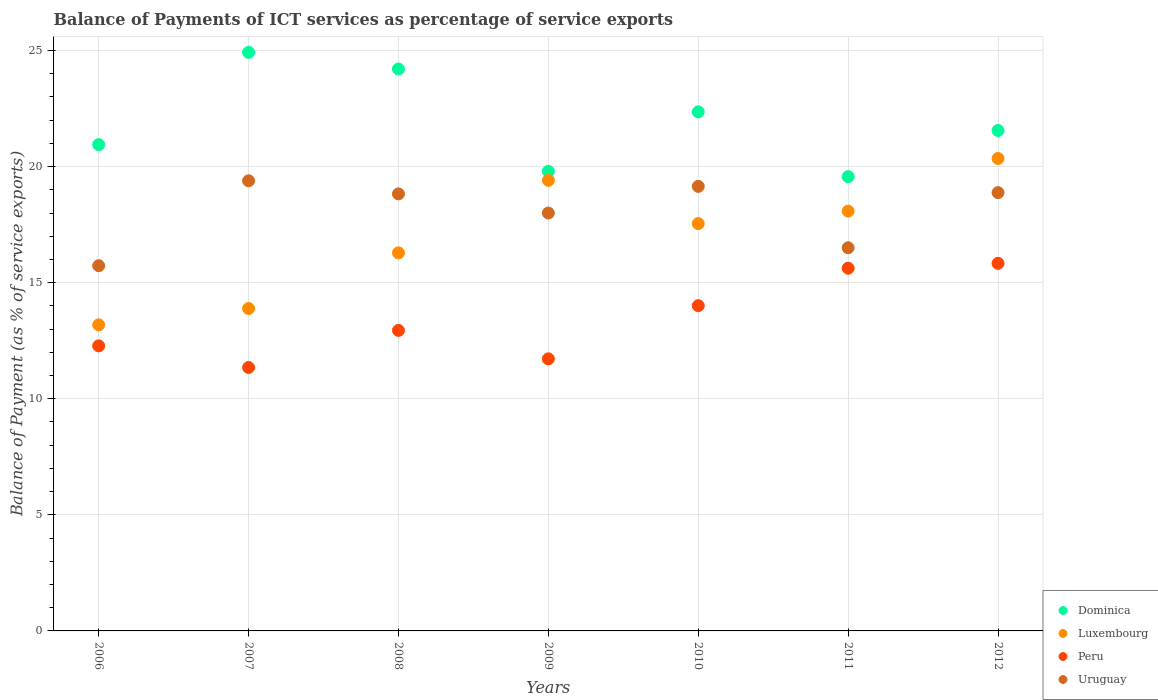How many different coloured dotlines are there?
Provide a short and direct response. 4. Is the number of dotlines equal to the number of legend labels?
Offer a very short reply. Yes. What is the balance of payments of ICT services in Dominica in 2007?
Ensure brevity in your answer.  24.92. Across all years, what is the maximum balance of payments of ICT services in Dominica?
Your answer should be very brief. 24.92. Across all years, what is the minimum balance of payments of ICT services in Peru?
Offer a terse response. 11.35. In which year was the balance of payments of ICT services in Luxembourg maximum?
Give a very brief answer. 2012. What is the total balance of payments of ICT services in Uruguay in the graph?
Keep it short and to the point. 126.48. What is the difference between the balance of payments of ICT services in Luxembourg in 2009 and that in 2011?
Keep it short and to the point. 1.33. What is the difference between the balance of payments of ICT services in Peru in 2010 and the balance of payments of ICT services in Dominica in 2008?
Give a very brief answer. -10.19. What is the average balance of payments of ICT services in Luxembourg per year?
Offer a very short reply. 16.96. In the year 2011, what is the difference between the balance of payments of ICT services in Peru and balance of payments of ICT services in Uruguay?
Offer a very short reply. -0.88. In how many years, is the balance of payments of ICT services in Peru greater than 3 %?
Offer a very short reply. 7. What is the ratio of the balance of payments of ICT services in Dominica in 2009 to that in 2011?
Keep it short and to the point. 1.01. Is the balance of payments of ICT services in Dominica in 2007 less than that in 2012?
Make the answer very short. No. What is the difference between the highest and the second highest balance of payments of ICT services in Dominica?
Keep it short and to the point. 0.72. What is the difference between the highest and the lowest balance of payments of ICT services in Dominica?
Make the answer very short. 5.36. In how many years, is the balance of payments of ICT services in Luxembourg greater than the average balance of payments of ICT services in Luxembourg taken over all years?
Your answer should be very brief. 4. Is the sum of the balance of payments of ICT services in Luxembourg in 2009 and 2010 greater than the maximum balance of payments of ICT services in Peru across all years?
Your response must be concise. Yes. Is it the case that in every year, the sum of the balance of payments of ICT services in Dominica and balance of payments of ICT services in Uruguay  is greater than the sum of balance of payments of ICT services in Luxembourg and balance of payments of ICT services in Peru?
Your response must be concise. No. Is it the case that in every year, the sum of the balance of payments of ICT services in Luxembourg and balance of payments of ICT services in Dominica  is greater than the balance of payments of ICT services in Peru?
Keep it short and to the point. Yes. How many years are there in the graph?
Your answer should be compact. 7. Are the values on the major ticks of Y-axis written in scientific E-notation?
Give a very brief answer. No. Does the graph contain grids?
Give a very brief answer. Yes. What is the title of the graph?
Your answer should be very brief. Balance of Payments of ICT services as percentage of service exports. What is the label or title of the X-axis?
Ensure brevity in your answer.  Years. What is the label or title of the Y-axis?
Make the answer very short. Balance of Payment (as % of service exports). What is the Balance of Payment (as % of service exports) in Dominica in 2006?
Your answer should be very brief. 20.95. What is the Balance of Payment (as % of service exports) of Luxembourg in 2006?
Your answer should be very brief. 13.18. What is the Balance of Payment (as % of service exports) of Peru in 2006?
Make the answer very short. 12.28. What is the Balance of Payment (as % of service exports) of Uruguay in 2006?
Your response must be concise. 15.73. What is the Balance of Payment (as % of service exports) of Dominica in 2007?
Keep it short and to the point. 24.92. What is the Balance of Payment (as % of service exports) in Luxembourg in 2007?
Offer a very short reply. 13.89. What is the Balance of Payment (as % of service exports) in Peru in 2007?
Your answer should be very brief. 11.35. What is the Balance of Payment (as % of service exports) in Uruguay in 2007?
Give a very brief answer. 19.39. What is the Balance of Payment (as % of service exports) of Dominica in 2008?
Your response must be concise. 24.2. What is the Balance of Payment (as % of service exports) in Luxembourg in 2008?
Give a very brief answer. 16.28. What is the Balance of Payment (as % of service exports) of Peru in 2008?
Provide a succinct answer. 12.94. What is the Balance of Payment (as % of service exports) in Uruguay in 2008?
Offer a very short reply. 18.83. What is the Balance of Payment (as % of service exports) of Dominica in 2009?
Keep it short and to the point. 19.8. What is the Balance of Payment (as % of service exports) in Luxembourg in 2009?
Make the answer very short. 19.41. What is the Balance of Payment (as % of service exports) of Peru in 2009?
Provide a short and direct response. 11.72. What is the Balance of Payment (as % of service exports) in Uruguay in 2009?
Provide a short and direct response. 18. What is the Balance of Payment (as % of service exports) of Dominica in 2010?
Provide a succinct answer. 22.36. What is the Balance of Payment (as % of service exports) in Luxembourg in 2010?
Provide a short and direct response. 17.55. What is the Balance of Payment (as % of service exports) in Peru in 2010?
Your answer should be compact. 14.01. What is the Balance of Payment (as % of service exports) in Uruguay in 2010?
Your answer should be compact. 19.15. What is the Balance of Payment (as % of service exports) of Dominica in 2011?
Keep it short and to the point. 19.57. What is the Balance of Payment (as % of service exports) in Luxembourg in 2011?
Offer a terse response. 18.08. What is the Balance of Payment (as % of service exports) in Peru in 2011?
Provide a succinct answer. 15.62. What is the Balance of Payment (as % of service exports) of Uruguay in 2011?
Give a very brief answer. 16.5. What is the Balance of Payment (as % of service exports) in Dominica in 2012?
Make the answer very short. 21.56. What is the Balance of Payment (as % of service exports) in Luxembourg in 2012?
Provide a short and direct response. 20.35. What is the Balance of Payment (as % of service exports) in Peru in 2012?
Provide a short and direct response. 15.83. What is the Balance of Payment (as % of service exports) of Uruguay in 2012?
Your answer should be compact. 18.88. Across all years, what is the maximum Balance of Payment (as % of service exports) in Dominica?
Ensure brevity in your answer.  24.92. Across all years, what is the maximum Balance of Payment (as % of service exports) of Luxembourg?
Keep it short and to the point. 20.35. Across all years, what is the maximum Balance of Payment (as % of service exports) of Peru?
Your answer should be very brief. 15.83. Across all years, what is the maximum Balance of Payment (as % of service exports) in Uruguay?
Offer a terse response. 19.39. Across all years, what is the minimum Balance of Payment (as % of service exports) of Dominica?
Provide a short and direct response. 19.57. Across all years, what is the minimum Balance of Payment (as % of service exports) of Luxembourg?
Your response must be concise. 13.18. Across all years, what is the minimum Balance of Payment (as % of service exports) of Peru?
Keep it short and to the point. 11.35. Across all years, what is the minimum Balance of Payment (as % of service exports) in Uruguay?
Provide a succinct answer. 15.73. What is the total Balance of Payment (as % of service exports) of Dominica in the graph?
Make the answer very short. 153.35. What is the total Balance of Payment (as % of service exports) of Luxembourg in the graph?
Give a very brief answer. 118.74. What is the total Balance of Payment (as % of service exports) in Peru in the graph?
Provide a succinct answer. 93.76. What is the total Balance of Payment (as % of service exports) of Uruguay in the graph?
Make the answer very short. 126.48. What is the difference between the Balance of Payment (as % of service exports) of Dominica in 2006 and that in 2007?
Offer a very short reply. -3.98. What is the difference between the Balance of Payment (as % of service exports) of Luxembourg in 2006 and that in 2007?
Offer a very short reply. -0.7. What is the difference between the Balance of Payment (as % of service exports) of Peru in 2006 and that in 2007?
Keep it short and to the point. 0.93. What is the difference between the Balance of Payment (as % of service exports) in Uruguay in 2006 and that in 2007?
Offer a very short reply. -3.66. What is the difference between the Balance of Payment (as % of service exports) of Dominica in 2006 and that in 2008?
Ensure brevity in your answer.  -3.26. What is the difference between the Balance of Payment (as % of service exports) in Luxembourg in 2006 and that in 2008?
Make the answer very short. -3.1. What is the difference between the Balance of Payment (as % of service exports) of Peru in 2006 and that in 2008?
Provide a short and direct response. -0.67. What is the difference between the Balance of Payment (as % of service exports) of Uruguay in 2006 and that in 2008?
Provide a succinct answer. -3.09. What is the difference between the Balance of Payment (as % of service exports) of Dominica in 2006 and that in 2009?
Make the answer very short. 1.15. What is the difference between the Balance of Payment (as % of service exports) of Luxembourg in 2006 and that in 2009?
Give a very brief answer. -6.22. What is the difference between the Balance of Payment (as % of service exports) in Peru in 2006 and that in 2009?
Offer a very short reply. 0.56. What is the difference between the Balance of Payment (as % of service exports) in Uruguay in 2006 and that in 2009?
Provide a short and direct response. -2.27. What is the difference between the Balance of Payment (as % of service exports) in Dominica in 2006 and that in 2010?
Offer a terse response. -1.41. What is the difference between the Balance of Payment (as % of service exports) of Luxembourg in 2006 and that in 2010?
Provide a short and direct response. -4.36. What is the difference between the Balance of Payment (as % of service exports) of Peru in 2006 and that in 2010?
Your answer should be compact. -1.73. What is the difference between the Balance of Payment (as % of service exports) in Uruguay in 2006 and that in 2010?
Keep it short and to the point. -3.42. What is the difference between the Balance of Payment (as % of service exports) of Dominica in 2006 and that in 2011?
Keep it short and to the point. 1.38. What is the difference between the Balance of Payment (as % of service exports) in Luxembourg in 2006 and that in 2011?
Offer a very short reply. -4.9. What is the difference between the Balance of Payment (as % of service exports) in Peru in 2006 and that in 2011?
Ensure brevity in your answer.  -3.34. What is the difference between the Balance of Payment (as % of service exports) of Uruguay in 2006 and that in 2011?
Ensure brevity in your answer.  -0.77. What is the difference between the Balance of Payment (as % of service exports) of Dominica in 2006 and that in 2012?
Your response must be concise. -0.61. What is the difference between the Balance of Payment (as % of service exports) in Luxembourg in 2006 and that in 2012?
Your answer should be compact. -7.17. What is the difference between the Balance of Payment (as % of service exports) of Peru in 2006 and that in 2012?
Your answer should be very brief. -3.55. What is the difference between the Balance of Payment (as % of service exports) in Uruguay in 2006 and that in 2012?
Your answer should be compact. -3.15. What is the difference between the Balance of Payment (as % of service exports) of Dominica in 2007 and that in 2008?
Provide a succinct answer. 0.72. What is the difference between the Balance of Payment (as % of service exports) in Luxembourg in 2007 and that in 2008?
Offer a terse response. -2.4. What is the difference between the Balance of Payment (as % of service exports) in Peru in 2007 and that in 2008?
Offer a very short reply. -1.6. What is the difference between the Balance of Payment (as % of service exports) in Uruguay in 2007 and that in 2008?
Ensure brevity in your answer.  0.56. What is the difference between the Balance of Payment (as % of service exports) of Dominica in 2007 and that in 2009?
Provide a succinct answer. 5.12. What is the difference between the Balance of Payment (as % of service exports) of Luxembourg in 2007 and that in 2009?
Offer a very short reply. -5.52. What is the difference between the Balance of Payment (as % of service exports) of Peru in 2007 and that in 2009?
Offer a very short reply. -0.37. What is the difference between the Balance of Payment (as % of service exports) in Uruguay in 2007 and that in 2009?
Ensure brevity in your answer.  1.39. What is the difference between the Balance of Payment (as % of service exports) of Dominica in 2007 and that in 2010?
Keep it short and to the point. 2.56. What is the difference between the Balance of Payment (as % of service exports) in Luxembourg in 2007 and that in 2010?
Your answer should be very brief. -3.66. What is the difference between the Balance of Payment (as % of service exports) in Peru in 2007 and that in 2010?
Your answer should be very brief. -2.66. What is the difference between the Balance of Payment (as % of service exports) in Uruguay in 2007 and that in 2010?
Give a very brief answer. 0.24. What is the difference between the Balance of Payment (as % of service exports) in Dominica in 2007 and that in 2011?
Give a very brief answer. 5.36. What is the difference between the Balance of Payment (as % of service exports) in Luxembourg in 2007 and that in 2011?
Keep it short and to the point. -4.2. What is the difference between the Balance of Payment (as % of service exports) in Peru in 2007 and that in 2011?
Make the answer very short. -4.28. What is the difference between the Balance of Payment (as % of service exports) of Uruguay in 2007 and that in 2011?
Make the answer very short. 2.89. What is the difference between the Balance of Payment (as % of service exports) in Dominica in 2007 and that in 2012?
Your response must be concise. 3.37. What is the difference between the Balance of Payment (as % of service exports) in Luxembourg in 2007 and that in 2012?
Your answer should be compact. -6.46. What is the difference between the Balance of Payment (as % of service exports) of Peru in 2007 and that in 2012?
Offer a very short reply. -4.49. What is the difference between the Balance of Payment (as % of service exports) in Uruguay in 2007 and that in 2012?
Ensure brevity in your answer.  0.51. What is the difference between the Balance of Payment (as % of service exports) of Dominica in 2008 and that in 2009?
Provide a succinct answer. 4.4. What is the difference between the Balance of Payment (as % of service exports) in Luxembourg in 2008 and that in 2009?
Your answer should be compact. -3.12. What is the difference between the Balance of Payment (as % of service exports) of Peru in 2008 and that in 2009?
Offer a terse response. 1.22. What is the difference between the Balance of Payment (as % of service exports) in Uruguay in 2008 and that in 2009?
Your response must be concise. 0.83. What is the difference between the Balance of Payment (as % of service exports) in Dominica in 2008 and that in 2010?
Keep it short and to the point. 1.84. What is the difference between the Balance of Payment (as % of service exports) of Luxembourg in 2008 and that in 2010?
Your answer should be very brief. -1.26. What is the difference between the Balance of Payment (as % of service exports) of Peru in 2008 and that in 2010?
Your response must be concise. -1.07. What is the difference between the Balance of Payment (as % of service exports) of Uruguay in 2008 and that in 2010?
Offer a terse response. -0.32. What is the difference between the Balance of Payment (as % of service exports) in Dominica in 2008 and that in 2011?
Your answer should be compact. 4.64. What is the difference between the Balance of Payment (as % of service exports) in Luxembourg in 2008 and that in 2011?
Your answer should be very brief. -1.8. What is the difference between the Balance of Payment (as % of service exports) of Peru in 2008 and that in 2011?
Your response must be concise. -2.68. What is the difference between the Balance of Payment (as % of service exports) in Uruguay in 2008 and that in 2011?
Provide a succinct answer. 2.32. What is the difference between the Balance of Payment (as % of service exports) in Dominica in 2008 and that in 2012?
Provide a succinct answer. 2.65. What is the difference between the Balance of Payment (as % of service exports) in Luxembourg in 2008 and that in 2012?
Your answer should be compact. -4.07. What is the difference between the Balance of Payment (as % of service exports) in Peru in 2008 and that in 2012?
Your response must be concise. -2.89. What is the difference between the Balance of Payment (as % of service exports) in Uruguay in 2008 and that in 2012?
Give a very brief answer. -0.05. What is the difference between the Balance of Payment (as % of service exports) in Dominica in 2009 and that in 2010?
Keep it short and to the point. -2.56. What is the difference between the Balance of Payment (as % of service exports) of Luxembourg in 2009 and that in 2010?
Give a very brief answer. 1.86. What is the difference between the Balance of Payment (as % of service exports) in Peru in 2009 and that in 2010?
Give a very brief answer. -2.29. What is the difference between the Balance of Payment (as % of service exports) in Uruguay in 2009 and that in 2010?
Give a very brief answer. -1.15. What is the difference between the Balance of Payment (as % of service exports) of Dominica in 2009 and that in 2011?
Ensure brevity in your answer.  0.23. What is the difference between the Balance of Payment (as % of service exports) of Luxembourg in 2009 and that in 2011?
Give a very brief answer. 1.33. What is the difference between the Balance of Payment (as % of service exports) of Peru in 2009 and that in 2011?
Provide a short and direct response. -3.9. What is the difference between the Balance of Payment (as % of service exports) of Uruguay in 2009 and that in 2011?
Ensure brevity in your answer.  1.5. What is the difference between the Balance of Payment (as % of service exports) in Dominica in 2009 and that in 2012?
Your answer should be compact. -1.76. What is the difference between the Balance of Payment (as % of service exports) in Luxembourg in 2009 and that in 2012?
Your answer should be compact. -0.94. What is the difference between the Balance of Payment (as % of service exports) in Peru in 2009 and that in 2012?
Offer a terse response. -4.11. What is the difference between the Balance of Payment (as % of service exports) in Uruguay in 2009 and that in 2012?
Give a very brief answer. -0.88. What is the difference between the Balance of Payment (as % of service exports) in Dominica in 2010 and that in 2011?
Give a very brief answer. 2.79. What is the difference between the Balance of Payment (as % of service exports) of Luxembourg in 2010 and that in 2011?
Offer a very short reply. -0.54. What is the difference between the Balance of Payment (as % of service exports) of Peru in 2010 and that in 2011?
Provide a short and direct response. -1.61. What is the difference between the Balance of Payment (as % of service exports) in Uruguay in 2010 and that in 2011?
Your answer should be compact. 2.64. What is the difference between the Balance of Payment (as % of service exports) of Dominica in 2010 and that in 2012?
Your answer should be compact. 0.8. What is the difference between the Balance of Payment (as % of service exports) in Luxembourg in 2010 and that in 2012?
Your answer should be compact. -2.8. What is the difference between the Balance of Payment (as % of service exports) of Peru in 2010 and that in 2012?
Keep it short and to the point. -1.82. What is the difference between the Balance of Payment (as % of service exports) of Uruguay in 2010 and that in 2012?
Ensure brevity in your answer.  0.27. What is the difference between the Balance of Payment (as % of service exports) in Dominica in 2011 and that in 2012?
Provide a succinct answer. -1.99. What is the difference between the Balance of Payment (as % of service exports) in Luxembourg in 2011 and that in 2012?
Make the answer very short. -2.27. What is the difference between the Balance of Payment (as % of service exports) in Peru in 2011 and that in 2012?
Keep it short and to the point. -0.21. What is the difference between the Balance of Payment (as % of service exports) in Uruguay in 2011 and that in 2012?
Make the answer very short. -2.38. What is the difference between the Balance of Payment (as % of service exports) of Dominica in 2006 and the Balance of Payment (as % of service exports) of Luxembourg in 2007?
Your answer should be compact. 7.06. What is the difference between the Balance of Payment (as % of service exports) of Dominica in 2006 and the Balance of Payment (as % of service exports) of Peru in 2007?
Make the answer very short. 9.6. What is the difference between the Balance of Payment (as % of service exports) of Dominica in 2006 and the Balance of Payment (as % of service exports) of Uruguay in 2007?
Give a very brief answer. 1.56. What is the difference between the Balance of Payment (as % of service exports) of Luxembourg in 2006 and the Balance of Payment (as % of service exports) of Peru in 2007?
Your answer should be compact. 1.84. What is the difference between the Balance of Payment (as % of service exports) in Luxembourg in 2006 and the Balance of Payment (as % of service exports) in Uruguay in 2007?
Your answer should be compact. -6.21. What is the difference between the Balance of Payment (as % of service exports) in Peru in 2006 and the Balance of Payment (as % of service exports) in Uruguay in 2007?
Provide a succinct answer. -7.11. What is the difference between the Balance of Payment (as % of service exports) of Dominica in 2006 and the Balance of Payment (as % of service exports) of Luxembourg in 2008?
Provide a short and direct response. 4.66. What is the difference between the Balance of Payment (as % of service exports) of Dominica in 2006 and the Balance of Payment (as % of service exports) of Peru in 2008?
Give a very brief answer. 8. What is the difference between the Balance of Payment (as % of service exports) in Dominica in 2006 and the Balance of Payment (as % of service exports) in Uruguay in 2008?
Your answer should be very brief. 2.12. What is the difference between the Balance of Payment (as % of service exports) of Luxembourg in 2006 and the Balance of Payment (as % of service exports) of Peru in 2008?
Your answer should be very brief. 0.24. What is the difference between the Balance of Payment (as % of service exports) of Luxembourg in 2006 and the Balance of Payment (as % of service exports) of Uruguay in 2008?
Your answer should be very brief. -5.64. What is the difference between the Balance of Payment (as % of service exports) in Peru in 2006 and the Balance of Payment (as % of service exports) in Uruguay in 2008?
Give a very brief answer. -6.55. What is the difference between the Balance of Payment (as % of service exports) in Dominica in 2006 and the Balance of Payment (as % of service exports) in Luxembourg in 2009?
Your response must be concise. 1.54. What is the difference between the Balance of Payment (as % of service exports) of Dominica in 2006 and the Balance of Payment (as % of service exports) of Peru in 2009?
Ensure brevity in your answer.  9.23. What is the difference between the Balance of Payment (as % of service exports) in Dominica in 2006 and the Balance of Payment (as % of service exports) in Uruguay in 2009?
Provide a short and direct response. 2.95. What is the difference between the Balance of Payment (as % of service exports) of Luxembourg in 2006 and the Balance of Payment (as % of service exports) of Peru in 2009?
Keep it short and to the point. 1.46. What is the difference between the Balance of Payment (as % of service exports) in Luxembourg in 2006 and the Balance of Payment (as % of service exports) in Uruguay in 2009?
Ensure brevity in your answer.  -4.82. What is the difference between the Balance of Payment (as % of service exports) of Peru in 2006 and the Balance of Payment (as % of service exports) of Uruguay in 2009?
Keep it short and to the point. -5.72. What is the difference between the Balance of Payment (as % of service exports) in Dominica in 2006 and the Balance of Payment (as % of service exports) in Luxembourg in 2010?
Your answer should be very brief. 3.4. What is the difference between the Balance of Payment (as % of service exports) of Dominica in 2006 and the Balance of Payment (as % of service exports) of Peru in 2010?
Provide a succinct answer. 6.94. What is the difference between the Balance of Payment (as % of service exports) in Dominica in 2006 and the Balance of Payment (as % of service exports) in Uruguay in 2010?
Ensure brevity in your answer.  1.8. What is the difference between the Balance of Payment (as % of service exports) in Luxembourg in 2006 and the Balance of Payment (as % of service exports) in Peru in 2010?
Your answer should be very brief. -0.83. What is the difference between the Balance of Payment (as % of service exports) in Luxembourg in 2006 and the Balance of Payment (as % of service exports) in Uruguay in 2010?
Your answer should be compact. -5.96. What is the difference between the Balance of Payment (as % of service exports) of Peru in 2006 and the Balance of Payment (as % of service exports) of Uruguay in 2010?
Provide a short and direct response. -6.87. What is the difference between the Balance of Payment (as % of service exports) of Dominica in 2006 and the Balance of Payment (as % of service exports) of Luxembourg in 2011?
Offer a very short reply. 2.86. What is the difference between the Balance of Payment (as % of service exports) of Dominica in 2006 and the Balance of Payment (as % of service exports) of Peru in 2011?
Your response must be concise. 5.32. What is the difference between the Balance of Payment (as % of service exports) in Dominica in 2006 and the Balance of Payment (as % of service exports) in Uruguay in 2011?
Give a very brief answer. 4.44. What is the difference between the Balance of Payment (as % of service exports) in Luxembourg in 2006 and the Balance of Payment (as % of service exports) in Peru in 2011?
Make the answer very short. -2.44. What is the difference between the Balance of Payment (as % of service exports) of Luxembourg in 2006 and the Balance of Payment (as % of service exports) of Uruguay in 2011?
Give a very brief answer. -3.32. What is the difference between the Balance of Payment (as % of service exports) of Peru in 2006 and the Balance of Payment (as % of service exports) of Uruguay in 2011?
Your response must be concise. -4.22. What is the difference between the Balance of Payment (as % of service exports) in Dominica in 2006 and the Balance of Payment (as % of service exports) in Luxembourg in 2012?
Offer a very short reply. 0.6. What is the difference between the Balance of Payment (as % of service exports) of Dominica in 2006 and the Balance of Payment (as % of service exports) of Peru in 2012?
Provide a succinct answer. 5.11. What is the difference between the Balance of Payment (as % of service exports) in Dominica in 2006 and the Balance of Payment (as % of service exports) in Uruguay in 2012?
Keep it short and to the point. 2.07. What is the difference between the Balance of Payment (as % of service exports) of Luxembourg in 2006 and the Balance of Payment (as % of service exports) of Peru in 2012?
Offer a very short reply. -2.65. What is the difference between the Balance of Payment (as % of service exports) in Luxembourg in 2006 and the Balance of Payment (as % of service exports) in Uruguay in 2012?
Provide a short and direct response. -5.7. What is the difference between the Balance of Payment (as % of service exports) in Peru in 2006 and the Balance of Payment (as % of service exports) in Uruguay in 2012?
Your answer should be compact. -6.6. What is the difference between the Balance of Payment (as % of service exports) of Dominica in 2007 and the Balance of Payment (as % of service exports) of Luxembourg in 2008?
Give a very brief answer. 8.64. What is the difference between the Balance of Payment (as % of service exports) in Dominica in 2007 and the Balance of Payment (as % of service exports) in Peru in 2008?
Provide a succinct answer. 11.98. What is the difference between the Balance of Payment (as % of service exports) of Dominica in 2007 and the Balance of Payment (as % of service exports) of Uruguay in 2008?
Offer a terse response. 6.1. What is the difference between the Balance of Payment (as % of service exports) in Luxembourg in 2007 and the Balance of Payment (as % of service exports) in Peru in 2008?
Keep it short and to the point. 0.94. What is the difference between the Balance of Payment (as % of service exports) of Luxembourg in 2007 and the Balance of Payment (as % of service exports) of Uruguay in 2008?
Your response must be concise. -4.94. What is the difference between the Balance of Payment (as % of service exports) in Peru in 2007 and the Balance of Payment (as % of service exports) in Uruguay in 2008?
Give a very brief answer. -7.48. What is the difference between the Balance of Payment (as % of service exports) in Dominica in 2007 and the Balance of Payment (as % of service exports) in Luxembourg in 2009?
Give a very brief answer. 5.51. What is the difference between the Balance of Payment (as % of service exports) of Dominica in 2007 and the Balance of Payment (as % of service exports) of Peru in 2009?
Provide a short and direct response. 13.2. What is the difference between the Balance of Payment (as % of service exports) in Dominica in 2007 and the Balance of Payment (as % of service exports) in Uruguay in 2009?
Offer a terse response. 6.92. What is the difference between the Balance of Payment (as % of service exports) of Luxembourg in 2007 and the Balance of Payment (as % of service exports) of Peru in 2009?
Your answer should be compact. 2.17. What is the difference between the Balance of Payment (as % of service exports) in Luxembourg in 2007 and the Balance of Payment (as % of service exports) in Uruguay in 2009?
Your response must be concise. -4.11. What is the difference between the Balance of Payment (as % of service exports) of Peru in 2007 and the Balance of Payment (as % of service exports) of Uruguay in 2009?
Offer a terse response. -6.65. What is the difference between the Balance of Payment (as % of service exports) of Dominica in 2007 and the Balance of Payment (as % of service exports) of Luxembourg in 2010?
Give a very brief answer. 7.38. What is the difference between the Balance of Payment (as % of service exports) of Dominica in 2007 and the Balance of Payment (as % of service exports) of Peru in 2010?
Provide a succinct answer. 10.91. What is the difference between the Balance of Payment (as % of service exports) of Dominica in 2007 and the Balance of Payment (as % of service exports) of Uruguay in 2010?
Offer a very short reply. 5.77. What is the difference between the Balance of Payment (as % of service exports) in Luxembourg in 2007 and the Balance of Payment (as % of service exports) in Peru in 2010?
Provide a short and direct response. -0.12. What is the difference between the Balance of Payment (as % of service exports) of Luxembourg in 2007 and the Balance of Payment (as % of service exports) of Uruguay in 2010?
Provide a short and direct response. -5.26. What is the difference between the Balance of Payment (as % of service exports) of Peru in 2007 and the Balance of Payment (as % of service exports) of Uruguay in 2010?
Make the answer very short. -7.8. What is the difference between the Balance of Payment (as % of service exports) of Dominica in 2007 and the Balance of Payment (as % of service exports) of Luxembourg in 2011?
Ensure brevity in your answer.  6.84. What is the difference between the Balance of Payment (as % of service exports) in Dominica in 2007 and the Balance of Payment (as % of service exports) in Peru in 2011?
Ensure brevity in your answer.  9.3. What is the difference between the Balance of Payment (as % of service exports) in Dominica in 2007 and the Balance of Payment (as % of service exports) in Uruguay in 2011?
Offer a terse response. 8.42. What is the difference between the Balance of Payment (as % of service exports) of Luxembourg in 2007 and the Balance of Payment (as % of service exports) of Peru in 2011?
Provide a short and direct response. -1.74. What is the difference between the Balance of Payment (as % of service exports) in Luxembourg in 2007 and the Balance of Payment (as % of service exports) in Uruguay in 2011?
Your answer should be very brief. -2.62. What is the difference between the Balance of Payment (as % of service exports) in Peru in 2007 and the Balance of Payment (as % of service exports) in Uruguay in 2011?
Keep it short and to the point. -5.16. What is the difference between the Balance of Payment (as % of service exports) of Dominica in 2007 and the Balance of Payment (as % of service exports) of Luxembourg in 2012?
Keep it short and to the point. 4.57. What is the difference between the Balance of Payment (as % of service exports) of Dominica in 2007 and the Balance of Payment (as % of service exports) of Peru in 2012?
Keep it short and to the point. 9.09. What is the difference between the Balance of Payment (as % of service exports) in Dominica in 2007 and the Balance of Payment (as % of service exports) in Uruguay in 2012?
Keep it short and to the point. 6.04. What is the difference between the Balance of Payment (as % of service exports) of Luxembourg in 2007 and the Balance of Payment (as % of service exports) of Peru in 2012?
Offer a terse response. -1.95. What is the difference between the Balance of Payment (as % of service exports) of Luxembourg in 2007 and the Balance of Payment (as % of service exports) of Uruguay in 2012?
Your answer should be very brief. -4.99. What is the difference between the Balance of Payment (as % of service exports) in Peru in 2007 and the Balance of Payment (as % of service exports) in Uruguay in 2012?
Provide a succinct answer. -7.53. What is the difference between the Balance of Payment (as % of service exports) in Dominica in 2008 and the Balance of Payment (as % of service exports) in Luxembourg in 2009?
Your response must be concise. 4.8. What is the difference between the Balance of Payment (as % of service exports) in Dominica in 2008 and the Balance of Payment (as % of service exports) in Peru in 2009?
Offer a terse response. 12.48. What is the difference between the Balance of Payment (as % of service exports) of Dominica in 2008 and the Balance of Payment (as % of service exports) of Uruguay in 2009?
Offer a very short reply. 6.2. What is the difference between the Balance of Payment (as % of service exports) in Luxembourg in 2008 and the Balance of Payment (as % of service exports) in Peru in 2009?
Ensure brevity in your answer.  4.56. What is the difference between the Balance of Payment (as % of service exports) in Luxembourg in 2008 and the Balance of Payment (as % of service exports) in Uruguay in 2009?
Provide a succinct answer. -1.72. What is the difference between the Balance of Payment (as % of service exports) of Peru in 2008 and the Balance of Payment (as % of service exports) of Uruguay in 2009?
Your response must be concise. -5.06. What is the difference between the Balance of Payment (as % of service exports) in Dominica in 2008 and the Balance of Payment (as % of service exports) in Luxembourg in 2010?
Your response must be concise. 6.66. What is the difference between the Balance of Payment (as % of service exports) of Dominica in 2008 and the Balance of Payment (as % of service exports) of Peru in 2010?
Your response must be concise. 10.19. What is the difference between the Balance of Payment (as % of service exports) of Dominica in 2008 and the Balance of Payment (as % of service exports) of Uruguay in 2010?
Offer a very short reply. 5.05. What is the difference between the Balance of Payment (as % of service exports) in Luxembourg in 2008 and the Balance of Payment (as % of service exports) in Peru in 2010?
Your answer should be compact. 2.27. What is the difference between the Balance of Payment (as % of service exports) in Luxembourg in 2008 and the Balance of Payment (as % of service exports) in Uruguay in 2010?
Ensure brevity in your answer.  -2.86. What is the difference between the Balance of Payment (as % of service exports) of Peru in 2008 and the Balance of Payment (as % of service exports) of Uruguay in 2010?
Keep it short and to the point. -6.2. What is the difference between the Balance of Payment (as % of service exports) in Dominica in 2008 and the Balance of Payment (as % of service exports) in Luxembourg in 2011?
Ensure brevity in your answer.  6.12. What is the difference between the Balance of Payment (as % of service exports) in Dominica in 2008 and the Balance of Payment (as % of service exports) in Peru in 2011?
Your answer should be compact. 8.58. What is the difference between the Balance of Payment (as % of service exports) in Dominica in 2008 and the Balance of Payment (as % of service exports) in Uruguay in 2011?
Offer a very short reply. 7.7. What is the difference between the Balance of Payment (as % of service exports) of Luxembourg in 2008 and the Balance of Payment (as % of service exports) of Peru in 2011?
Make the answer very short. 0.66. What is the difference between the Balance of Payment (as % of service exports) of Luxembourg in 2008 and the Balance of Payment (as % of service exports) of Uruguay in 2011?
Your answer should be compact. -0.22. What is the difference between the Balance of Payment (as % of service exports) of Peru in 2008 and the Balance of Payment (as % of service exports) of Uruguay in 2011?
Provide a succinct answer. -3.56. What is the difference between the Balance of Payment (as % of service exports) in Dominica in 2008 and the Balance of Payment (as % of service exports) in Luxembourg in 2012?
Offer a terse response. 3.85. What is the difference between the Balance of Payment (as % of service exports) in Dominica in 2008 and the Balance of Payment (as % of service exports) in Peru in 2012?
Your answer should be very brief. 8.37. What is the difference between the Balance of Payment (as % of service exports) of Dominica in 2008 and the Balance of Payment (as % of service exports) of Uruguay in 2012?
Your answer should be compact. 5.32. What is the difference between the Balance of Payment (as % of service exports) of Luxembourg in 2008 and the Balance of Payment (as % of service exports) of Peru in 2012?
Your answer should be compact. 0.45. What is the difference between the Balance of Payment (as % of service exports) of Luxembourg in 2008 and the Balance of Payment (as % of service exports) of Uruguay in 2012?
Your answer should be very brief. -2.6. What is the difference between the Balance of Payment (as % of service exports) of Peru in 2008 and the Balance of Payment (as % of service exports) of Uruguay in 2012?
Offer a terse response. -5.94. What is the difference between the Balance of Payment (as % of service exports) of Dominica in 2009 and the Balance of Payment (as % of service exports) of Luxembourg in 2010?
Ensure brevity in your answer.  2.25. What is the difference between the Balance of Payment (as % of service exports) in Dominica in 2009 and the Balance of Payment (as % of service exports) in Peru in 2010?
Ensure brevity in your answer.  5.79. What is the difference between the Balance of Payment (as % of service exports) of Dominica in 2009 and the Balance of Payment (as % of service exports) of Uruguay in 2010?
Offer a very short reply. 0.65. What is the difference between the Balance of Payment (as % of service exports) of Luxembourg in 2009 and the Balance of Payment (as % of service exports) of Peru in 2010?
Your answer should be compact. 5.4. What is the difference between the Balance of Payment (as % of service exports) of Luxembourg in 2009 and the Balance of Payment (as % of service exports) of Uruguay in 2010?
Make the answer very short. 0.26. What is the difference between the Balance of Payment (as % of service exports) in Peru in 2009 and the Balance of Payment (as % of service exports) in Uruguay in 2010?
Provide a short and direct response. -7.43. What is the difference between the Balance of Payment (as % of service exports) of Dominica in 2009 and the Balance of Payment (as % of service exports) of Luxembourg in 2011?
Your answer should be compact. 1.72. What is the difference between the Balance of Payment (as % of service exports) of Dominica in 2009 and the Balance of Payment (as % of service exports) of Peru in 2011?
Ensure brevity in your answer.  4.18. What is the difference between the Balance of Payment (as % of service exports) of Dominica in 2009 and the Balance of Payment (as % of service exports) of Uruguay in 2011?
Ensure brevity in your answer.  3.3. What is the difference between the Balance of Payment (as % of service exports) of Luxembourg in 2009 and the Balance of Payment (as % of service exports) of Peru in 2011?
Offer a terse response. 3.78. What is the difference between the Balance of Payment (as % of service exports) in Luxembourg in 2009 and the Balance of Payment (as % of service exports) in Uruguay in 2011?
Make the answer very short. 2.9. What is the difference between the Balance of Payment (as % of service exports) of Peru in 2009 and the Balance of Payment (as % of service exports) of Uruguay in 2011?
Provide a short and direct response. -4.78. What is the difference between the Balance of Payment (as % of service exports) in Dominica in 2009 and the Balance of Payment (as % of service exports) in Luxembourg in 2012?
Your response must be concise. -0.55. What is the difference between the Balance of Payment (as % of service exports) of Dominica in 2009 and the Balance of Payment (as % of service exports) of Peru in 2012?
Offer a terse response. 3.97. What is the difference between the Balance of Payment (as % of service exports) in Dominica in 2009 and the Balance of Payment (as % of service exports) in Uruguay in 2012?
Ensure brevity in your answer.  0.92. What is the difference between the Balance of Payment (as % of service exports) of Luxembourg in 2009 and the Balance of Payment (as % of service exports) of Peru in 2012?
Keep it short and to the point. 3.58. What is the difference between the Balance of Payment (as % of service exports) in Luxembourg in 2009 and the Balance of Payment (as % of service exports) in Uruguay in 2012?
Offer a terse response. 0.53. What is the difference between the Balance of Payment (as % of service exports) in Peru in 2009 and the Balance of Payment (as % of service exports) in Uruguay in 2012?
Make the answer very short. -7.16. What is the difference between the Balance of Payment (as % of service exports) of Dominica in 2010 and the Balance of Payment (as % of service exports) of Luxembourg in 2011?
Offer a very short reply. 4.28. What is the difference between the Balance of Payment (as % of service exports) in Dominica in 2010 and the Balance of Payment (as % of service exports) in Peru in 2011?
Provide a short and direct response. 6.74. What is the difference between the Balance of Payment (as % of service exports) in Dominica in 2010 and the Balance of Payment (as % of service exports) in Uruguay in 2011?
Offer a terse response. 5.85. What is the difference between the Balance of Payment (as % of service exports) of Luxembourg in 2010 and the Balance of Payment (as % of service exports) of Peru in 2011?
Your answer should be very brief. 1.92. What is the difference between the Balance of Payment (as % of service exports) in Luxembourg in 2010 and the Balance of Payment (as % of service exports) in Uruguay in 2011?
Your answer should be very brief. 1.04. What is the difference between the Balance of Payment (as % of service exports) in Peru in 2010 and the Balance of Payment (as % of service exports) in Uruguay in 2011?
Give a very brief answer. -2.49. What is the difference between the Balance of Payment (as % of service exports) of Dominica in 2010 and the Balance of Payment (as % of service exports) of Luxembourg in 2012?
Your answer should be compact. 2.01. What is the difference between the Balance of Payment (as % of service exports) of Dominica in 2010 and the Balance of Payment (as % of service exports) of Peru in 2012?
Provide a short and direct response. 6.53. What is the difference between the Balance of Payment (as % of service exports) of Dominica in 2010 and the Balance of Payment (as % of service exports) of Uruguay in 2012?
Offer a terse response. 3.48. What is the difference between the Balance of Payment (as % of service exports) in Luxembourg in 2010 and the Balance of Payment (as % of service exports) in Peru in 2012?
Keep it short and to the point. 1.71. What is the difference between the Balance of Payment (as % of service exports) in Luxembourg in 2010 and the Balance of Payment (as % of service exports) in Uruguay in 2012?
Ensure brevity in your answer.  -1.33. What is the difference between the Balance of Payment (as % of service exports) in Peru in 2010 and the Balance of Payment (as % of service exports) in Uruguay in 2012?
Your response must be concise. -4.87. What is the difference between the Balance of Payment (as % of service exports) in Dominica in 2011 and the Balance of Payment (as % of service exports) in Luxembourg in 2012?
Keep it short and to the point. -0.78. What is the difference between the Balance of Payment (as % of service exports) in Dominica in 2011 and the Balance of Payment (as % of service exports) in Peru in 2012?
Your answer should be very brief. 3.73. What is the difference between the Balance of Payment (as % of service exports) in Dominica in 2011 and the Balance of Payment (as % of service exports) in Uruguay in 2012?
Your answer should be compact. 0.69. What is the difference between the Balance of Payment (as % of service exports) in Luxembourg in 2011 and the Balance of Payment (as % of service exports) in Peru in 2012?
Your response must be concise. 2.25. What is the difference between the Balance of Payment (as % of service exports) of Luxembourg in 2011 and the Balance of Payment (as % of service exports) of Uruguay in 2012?
Provide a succinct answer. -0.8. What is the difference between the Balance of Payment (as % of service exports) in Peru in 2011 and the Balance of Payment (as % of service exports) in Uruguay in 2012?
Make the answer very short. -3.26. What is the average Balance of Payment (as % of service exports) of Dominica per year?
Keep it short and to the point. 21.91. What is the average Balance of Payment (as % of service exports) in Luxembourg per year?
Offer a very short reply. 16.96. What is the average Balance of Payment (as % of service exports) in Peru per year?
Provide a succinct answer. 13.39. What is the average Balance of Payment (as % of service exports) of Uruguay per year?
Make the answer very short. 18.07. In the year 2006, what is the difference between the Balance of Payment (as % of service exports) in Dominica and Balance of Payment (as % of service exports) in Luxembourg?
Offer a terse response. 7.76. In the year 2006, what is the difference between the Balance of Payment (as % of service exports) of Dominica and Balance of Payment (as % of service exports) of Peru?
Make the answer very short. 8.67. In the year 2006, what is the difference between the Balance of Payment (as % of service exports) of Dominica and Balance of Payment (as % of service exports) of Uruguay?
Offer a terse response. 5.21. In the year 2006, what is the difference between the Balance of Payment (as % of service exports) of Luxembourg and Balance of Payment (as % of service exports) of Peru?
Your answer should be compact. 0.9. In the year 2006, what is the difference between the Balance of Payment (as % of service exports) in Luxembourg and Balance of Payment (as % of service exports) in Uruguay?
Make the answer very short. -2.55. In the year 2006, what is the difference between the Balance of Payment (as % of service exports) of Peru and Balance of Payment (as % of service exports) of Uruguay?
Ensure brevity in your answer.  -3.45. In the year 2007, what is the difference between the Balance of Payment (as % of service exports) in Dominica and Balance of Payment (as % of service exports) in Luxembourg?
Provide a short and direct response. 11.04. In the year 2007, what is the difference between the Balance of Payment (as % of service exports) in Dominica and Balance of Payment (as % of service exports) in Peru?
Make the answer very short. 13.58. In the year 2007, what is the difference between the Balance of Payment (as % of service exports) in Dominica and Balance of Payment (as % of service exports) in Uruguay?
Your response must be concise. 5.53. In the year 2007, what is the difference between the Balance of Payment (as % of service exports) of Luxembourg and Balance of Payment (as % of service exports) of Peru?
Your answer should be very brief. 2.54. In the year 2007, what is the difference between the Balance of Payment (as % of service exports) of Luxembourg and Balance of Payment (as % of service exports) of Uruguay?
Ensure brevity in your answer.  -5.5. In the year 2007, what is the difference between the Balance of Payment (as % of service exports) of Peru and Balance of Payment (as % of service exports) of Uruguay?
Provide a short and direct response. -8.04. In the year 2008, what is the difference between the Balance of Payment (as % of service exports) in Dominica and Balance of Payment (as % of service exports) in Luxembourg?
Make the answer very short. 7.92. In the year 2008, what is the difference between the Balance of Payment (as % of service exports) of Dominica and Balance of Payment (as % of service exports) of Peru?
Ensure brevity in your answer.  11.26. In the year 2008, what is the difference between the Balance of Payment (as % of service exports) in Dominica and Balance of Payment (as % of service exports) in Uruguay?
Ensure brevity in your answer.  5.38. In the year 2008, what is the difference between the Balance of Payment (as % of service exports) in Luxembourg and Balance of Payment (as % of service exports) in Peru?
Offer a terse response. 3.34. In the year 2008, what is the difference between the Balance of Payment (as % of service exports) in Luxembourg and Balance of Payment (as % of service exports) in Uruguay?
Your response must be concise. -2.54. In the year 2008, what is the difference between the Balance of Payment (as % of service exports) of Peru and Balance of Payment (as % of service exports) of Uruguay?
Keep it short and to the point. -5.88. In the year 2009, what is the difference between the Balance of Payment (as % of service exports) in Dominica and Balance of Payment (as % of service exports) in Luxembourg?
Offer a terse response. 0.39. In the year 2009, what is the difference between the Balance of Payment (as % of service exports) in Dominica and Balance of Payment (as % of service exports) in Peru?
Provide a short and direct response. 8.08. In the year 2009, what is the difference between the Balance of Payment (as % of service exports) in Dominica and Balance of Payment (as % of service exports) in Uruguay?
Your answer should be very brief. 1.8. In the year 2009, what is the difference between the Balance of Payment (as % of service exports) of Luxembourg and Balance of Payment (as % of service exports) of Peru?
Ensure brevity in your answer.  7.69. In the year 2009, what is the difference between the Balance of Payment (as % of service exports) in Luxembourg and Balance of Payment (as % of service exports) in Uruguay?
Offer a very short reply. 1.41. In the year 2009, what is the difference between the Balance of Payment (as % of service exports) of Peru and Balance of Payment (as % of service exports) of Uruguay?
Keep it short and to the point. -6.28. In the year 2010, what is the difference between the Balance of Payment (as % of service exports) of Dominica and Balance of Payment (as % of service exports) of Luxembourg?
Keep it short and to the point. 4.81. In the year 2010, what is the difference between the Balance of Payment (as % of service exports) in Dominica and Balance of Payment (as % of service exports) in Peru?
Offer a very short reply. 8.35. In the year 2010, what is the difference between the Balance of Payment (as % of service exports) in Dominica and Balance of Payment (as % of service exports) in Uruguay?
Provide a short and direct response. 3.21. In the year 2010, what is the difference between the Balance of Payment (as % of service exports) of Luxembourg and Balance of Payment (as % of service exports) of Peru?
Provide a short and direct response. 3.54. In the year 2010, what is the difference between the Balance of Payment (as % of service exports) in Luxembourg and Balance of Payment (as % of service exports) in Uruguay?
Your answer should be very brief. -1.6. In the year 2010, what is the difference between the Balance of Payment (as % of service exports) of Peru and Balance of Payment (as % of service exports) of Uruguay?
Give a very brief answer. -5.14. In the year 2011, what is the difference between the Balance of Payment (as % of service exports) of Dominica and Balance of Payment (as % of service exports) of Luxembourg?
Provide a short and direct response. 1.48. In the year 2011, what is the difference between the Balance of Payment (as % of service exports) in Dominica and Balance of Payment (as % of service exports) in Peru?
Provide a succinct answer. 3.94. In the year 2011, what is the difference between the Balance of Payment (as % of service exports) in Dominica and Balance of Payment (as % of service exports) in Uruguay?
Offer a terse response. 3.06. In the year 2011, what is the difference between the Balance of Payment (as % of service exports) in Luxembourg and Balance of Payment (as % of service exports) in Peru?
Ensure brevity in your answer.  2.46. In the year 2011, what is the difference between the Balance of Payment (as % of service exports) of Luxembourg and Balance of Payment (as % of service exports) of Uruguay?
Ensure brevity in your answer.  1.58. In the year 2011, what is the difference between the Balance of Payment (as % of service exports) of Peru and Balance of Payment (as % of service exports) of Uruguay?
Offer a terse response. -0.88. In the year 2012, what is the difference between the Balance of Payment (as % of service exports) in Dominica and Balance of Payment (as % of service exports) in Luxembourg?
Keep it short and to the point. 1.21. In the year 2012, what is the difference between the Balance of Payment (as % of service exports) of Dominica and Balance of Payment (as % of service exports) of Peru?
Provide a succinct answer. 5.72. In the year 2012, what is the difference between the Balance of Payment (as % of service exports) in Dominica and Balance of Payment (as % of service exports) in Uruguay?
Your answer should be very brief. 2.68. In the year 2012, what is the difference between the Balance of Payment (as % of service exports) in Luxembourg and Balance of Payment (as % of service exports) in Peru?
Your answer should be compact. 4.52. In the year 2012, what is the difference between the Balance of Payment (as % of service exports) in Luxembourg and Balance of Payment (as % of service exports) in Uruguay?
Provide a short and direct response. 1.47. In the year 2012, what is the difference between the Balance of Payment (as % of service exports) in Peru and Balance of Payment (as % of service exports) in Uruguay?
Provide a short and direct response. -3.05. What is the ratio of the Balance of Payment (as % of service exports) of Dominica in 2006 to that in 2007?
Your answer should be very brief. 0.84. What is the ratio of the Balance of Payment (as % of service exports) in Luxembourg in 2006 to that in 2007?
Your response must be concise. 0.95. What is the ratio of the Balance of Payment (as % of service exports) of Peru in 2006 to that in 2007?
Offer a very short reply. 1.08. What is the ratio of the Balance of Payment (as % of service exports) of Uruguay in 2006 to that in 2007?
Make the answer very short. 0.81. What is the ratio of the Balance of Payment (as % of service exports) in Dominica in 2006 to that in 2008?
Ensure brevity in your answer.  0.87. What is the ratio of the Balance of Payment (as % of service exports) of Luxembourg in 2006 to that in 2008?
Ensure brevity in your answer.  0.81. What is the ratio of the Balance of Payment (as % of service exports) of Peru in 2006 to that in 2008?
Your answer should be very brief. 0.95. What is the ratio of the Balance of Payment (as % of service exports) in Uruguay in 2006 to that in 2008?
Offer a terse response. 0.84. What is the ratio of the Balance of Payment (as % of service exports) in Dominica in 2006 to that in 2009?
Provide a succinct answer. 1.06. What is the ratio of the Balance of Payment (as % of service exports) in Luxembourg in 2006 to that in 2009?
Keep it short and to the point. 0.68. What is the ratio of the Balance of Payment (as % of service exports) of Peru in 2006 to that in 2009?
Provide a succinct answer. 1.05. What is the ratio of the Balance of Payment (as % of service exports) of Uruguay in 2006 to that in 2009?
Provide a succinct answer. 0.87. What is the ratio of the Balance of Payment (as % of service exports) of Dominica in 2006 to that in 2010?
Your answer should be very brief. 0.94. What is the ratio of the Balance of Payment (as % of service exports) of Luxembourg in 2006 to that in 2010?
Your answer should be compact. 0.75. What is the ratio of the Balance of Payment (as % of service exports) of Peru in 2006 to that in 2010?
Your response must be concise. 0.88. What is the ratio of the Balance of Payment (as % of service exports) in Uruguay in 2006 to that in 2010?
Your answer should be very brief. 0.82. What is the ratio of the Balance of Payment (as % of service exports) in Dominica in 2006 to that in 2011?
Provide a short and direct response. 1.07. What is the ratio of the Balance of Payment (as % of service exports) in Luxembourg in 2006 to that in 2011?
Offer a terse response. 0.73. What is the ratio of the Balance of Payment (as % of service exports) in Peru in 2006 to that in 2011?
Ensure brevity in your answer.  0.79. What is the ratio of the Balance of Payment (as % of service exports) in Uruguay in 2006 to that in 2011?
Your answer should be very brief. 0.95. What is the ratio of the Balance of Payment (as % of service exports) of Dominica in 2006 to that in 2012?
Offer a very short reply. 0.97. What is the ratio of the Balance of Payment (as % of service exports) in Luxembourg in 2006 to that in 2012?
Your answer should be compact. 0.65. What is the ratio of the Balance of Payment (as % of service exports) of Peru in 2006 to that in 2012?
Give a very brief answer. 0.78. What is the ratio of the Balance of Payment (as % of service exports) of Uruguay in 2006 to that in 2012?
Your response must be concise. 0.83. What is the ratio of the Balance of Payment (as % of service exports) in Dominica in 2007 to that in 2008?
Provide a succinct answer. 1.03. What is the ratio of the Balance of Payment (as % of service exports) of Luxembourg in 2007 to that in 2008?
Your response must be concise. 0.85. What is the ratio of the Balance of Payment (as % of service exports) of Peru in 2007 to that in 2008?
Give a very brief answer. 0.88. What is the ratio of the Balance of Payment (as % of service exports) of Uruguay in 2007 to that in 2008?
Offer a terse response. 1.03. What is the ratio of the Balance of Payment (as % of service exports) in Dominica in 2007 to that in 2009?
Provide a short and direct response. 1.26. What is the ratio of the Balance of Payment (as % of service exports) in Luxembourg in 2007 to that in 2009?
Provide a short and direct response. 0.72. What is the ratio of the Balance of Payment (as % of service exports) in Peru in 2007 to that in 2009?
Your response must be concise. 0.97. What is the ratio of the Balance of Payment (as % of service exports) of Uruguay in 2007 to that in 2009?
Keep it short and to the point. 1.08. What is the ratio of the Balance of Payment (as % of service exports) in Dominica in 2007 to that in 2010?
Provide a succinct answer. 1.11. What is the ratio of the Balance of Payment (as % of service exports) of Luxembourg in 2007 to that in 2010?
Provide a succinct answer. 0.79. What is the ratio of the Balance of Payment (as % of service exports) of Peru in 2007 to that in 2010?
Provide a short and direct response. 0.81. What is the ratio of the Balance of Payment (as % of service exports) of Uruguay in 2007 to that in 2010?
Your answer should be very brief. 1.01. What is the ratio of the Balance of Payment (as % of service exports) of Dominica in 2007 to that in 2011?
Your answer should be compact. 1.27. What is the ratio of the Balance of Payment (as % of service exports) in Luxembourg in 2007 to that in 2011?
Your response must be concise. 0.77. What is the ratio of the Balance of Payment (as % of service exports) in Peru in 2007 to that in 2011?
Your answer should be compact. 0.73. What is the ratio of the Balance of Payment (as % of service exports) of Uruguay in 2007 to that in 2011?
Provide a succinct answer. 1.17. What is the ratio of the Balance of Payment (as % of service exports) of Dominica in 2007 to that in 2012?
Offer a terse response. 1.16. What is the ratio of the Balance of Payment (as % of service exports) of Luxembourg in 2007 to that in 2012?
Provide a succinct answer. 0.68. What is the ratio of the Balance of Payment (as % of service exports) in Peru in 2007 to that in 2012?
Give a very brief answer. 0.72. What is the ratio of the Balance of Payment (as % of service exports) of Dominica in 2008 to that in 2009?
Your response must be concise. 1.22. What is the ratio of the Balance of Payment (as % of service exports) in Luxembourg in 2008 to that in 2009?
Keep it short and to the point. 0.84. What is the ratio of the Balance of Payment (as % of service exports) in Peru in 2008 to that in 2009?
Your response must be concise. 1.1. What is the ratio of the Balance of Payment (as % of service exports) in Uruguay in 2008 to that in 2009?
Your answer should be very brief. 1.05. What is the ratio of the Balance of Payment (as % of service exports) of Dominica in 2008 to that in 2010?
Your answer should be compact. 1.08. What is the ratio of the Balance of Payment (as % of service exports) of Luxembourg in 2008 to that in 2010?
Provide a succinct answer. 0.93. What is the ratio of the Balance of Payment (as % of service exports) in Peru in 2008 to that in 2010?
Your answer should be very brief. 0.92. What is the ratio of the Balance of Payment (as % of service exports) in Uruguay in 2008 to that in 2010?
Give a very brief answer. 0.98. What is the ratio of the Balance of Payment (as % of service exports) in Dominica in 2008 to that in 2011?
Your answer should be compact. 1.24. What is the ratio of the Balance of Payment (as % of service exports) in Luxembourg in 2008 to that in 2011?
Your response must be concise. 0.9. What is the ratio of the Balance of Payment (as % of service exports) of Peru in 2008 to that in 2011?
Your answer should be compact. 0.83. What is the ratio of the Balance of Payment (as % of service exports) of Uruguay in 2008 to that in 2011?
Give a very brief answer. 1.14. What is the ratio of the Balance of Payment (as % of service exports) in Dominica in 2008 to that in 2012?
Give a very brief answer. 1.12. What is the ratio of the Balance of Payment (as % of service exports) in Luxembourg in 2008 to that in 2012?
Your answer should be very brief. 0.8. What is the ratio of the Balance of Payment (as % of service exports) in Peru in 2008 to that in 2012?
Provide a short and direct response. 0.82. What is the ratio of the Balance of Payment (as % of service exports) in Dominica in 2009 to that in 2010?
Offer a very short reply. 0.89. What is the ratio of the Balance of Payment (as % of service exports) of Luxembourg in 2009 to that in 2010?
Provide a succinct answer. 1.11. What is the ratio of the Balance of Payment (as % of service exports) in Peru in 2009 to that in 2010?
Your answer should be very brief. 0.84. What is the ratio of the Balance of Payment (as % of service exports) of Uruguay in 2009 to that in 2010?
Offer a terse response. 0.94. What is the ratio of the Balance of Payment (as % of service exports) in Dominica in 2009 to that in 2011?
Your answer should be compact. 1.01. What is the ratio of the Balance of Payment (as % of service exports) of Luxembourg in 2009 to that in 2011?
Ensure brevity in your answer.  1.07. What is the ratio of the Balance of Payment (as % of service exports) of Peru in 2009 to that in 2011?
Offer a very short reply. 0.75. What is the ratio of the Balance of Payment (as % of service exports) in Uruguay in 2009 to that in 2011?
Give a very brief answer. 1.09. What is the ratio of the Balance of Payment (as % of service exports) in Dominica in 2009 to that in 2012?
Provide a succinct answer. 0.92. What is the ratio of the Balance of Payment (as % of service exports) in Luxembourg in 2009 to that in 2012?
Provide a succinct answer. 0.95. What is the ratio of the Balance of Payment (as % of service exports) of Peru in 2009 to that in 2012?
Provide a short and direct response. 0.74. What is the ratio of the Balance of Payment (as % of service exports) of Uruguay in 2009 to that in 2012?
Make the answer very short. 0.95. What is the ratio of the Balance of Payment (as % of service exports) of Dominica in 2010 to that in 2011?
Provide a succinct answer. 1.14. What is the ratio of the Balance of Payment (as % of service exports) of Luxembourg in 2010 to that in 2011?
Make the answer very short. 0.97. What is the ratio of the Balance of Payment (as % of service exports) in Peru in 2010 to that in 2011?
Your answer should be very brief. 0.9. What is the ratio of the Balance of Payment (as % of service exports) of Uruguay in 2010 to that in 2011?
Offer a terse response. 1.16. What is the ratio of the Balance of Payment (as % of service exports) in Dominica in 2010 to that in 2012?
Offer a very short reply. 1.04. What is the ratio of the Balance of Payment (as % of service exports) in Luxembourg in 2010 to that in 2012?
Your answer should be compact. 0.86. What is the ratio of the Balance of Payment (as % of service exports) of Peru in 2010 to that in 2012?
Give a very brief answer. 0.88. What is the ratio of the Balance of Payment (as % of service exports) in Uruguay in 2010 to that in 2012?
Your answer should be very brief. 1.01. What is the ratio of the Balance of Payment (as % of service exports) in Dominica in 2011 to that in 2012?
Offer a terse response. 0.91. What is the ratio of the Balance of Payment (as % of service exports) in Luxembourg in 2011 to that in 2012?
Offer a terse response. 0.89. What is the ratio of the Balance of Payment (as % of service exports) in Uruguay in 2011 to that in 2012?
Provide a succinct answer. 0.87. What is the difference between the highest and the second highest Balance of Payment (as % of service exports) in Dominica?
Your response must be concise. 0.72. What is the difference between the highest and the second highest Balance of Payment (as % of service exports) of Luxembourg?
Keep it short and to the point. 0.94. What is the difference between the highest and the second highest Balance of Payment (as % of service exports) in Peru?
Your response must be concise. 0.21. What is the difference between the highest and the second highest Balance of Payment (as % of service exports) of Uruguay?
Your answer should be compact. 0.24. What is the difference between the highest and the lowest Balance of Payment (as % of service exports) in Dominica?
Give a very brief answer. 5.36. What is the difference between the highest and the lowest Balance of Payment (as % of service exports) in Luxembourg?
Give a very brief answer. 7.17. What is the difference between the highest and the lowest Balance of Payment (as % of service exports) of Peru?
Offer a very short reply. 4.49. What is the difference between the highest and the lowest Balance of Payment (as % of service exports) in Uruguay?
Your answer should be very brief. 3.66. 